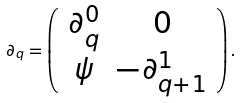<formula> <loc_0><loc_0><loc_500><loc_500>\partial _ { q } = \left ( \begin{array} { c c } \partial _ { q } ^ { 0 } & 0 \\ \psi & - \partial _ { q + 1 } ^ { 1 } \end{array} \right ) .</formula> 